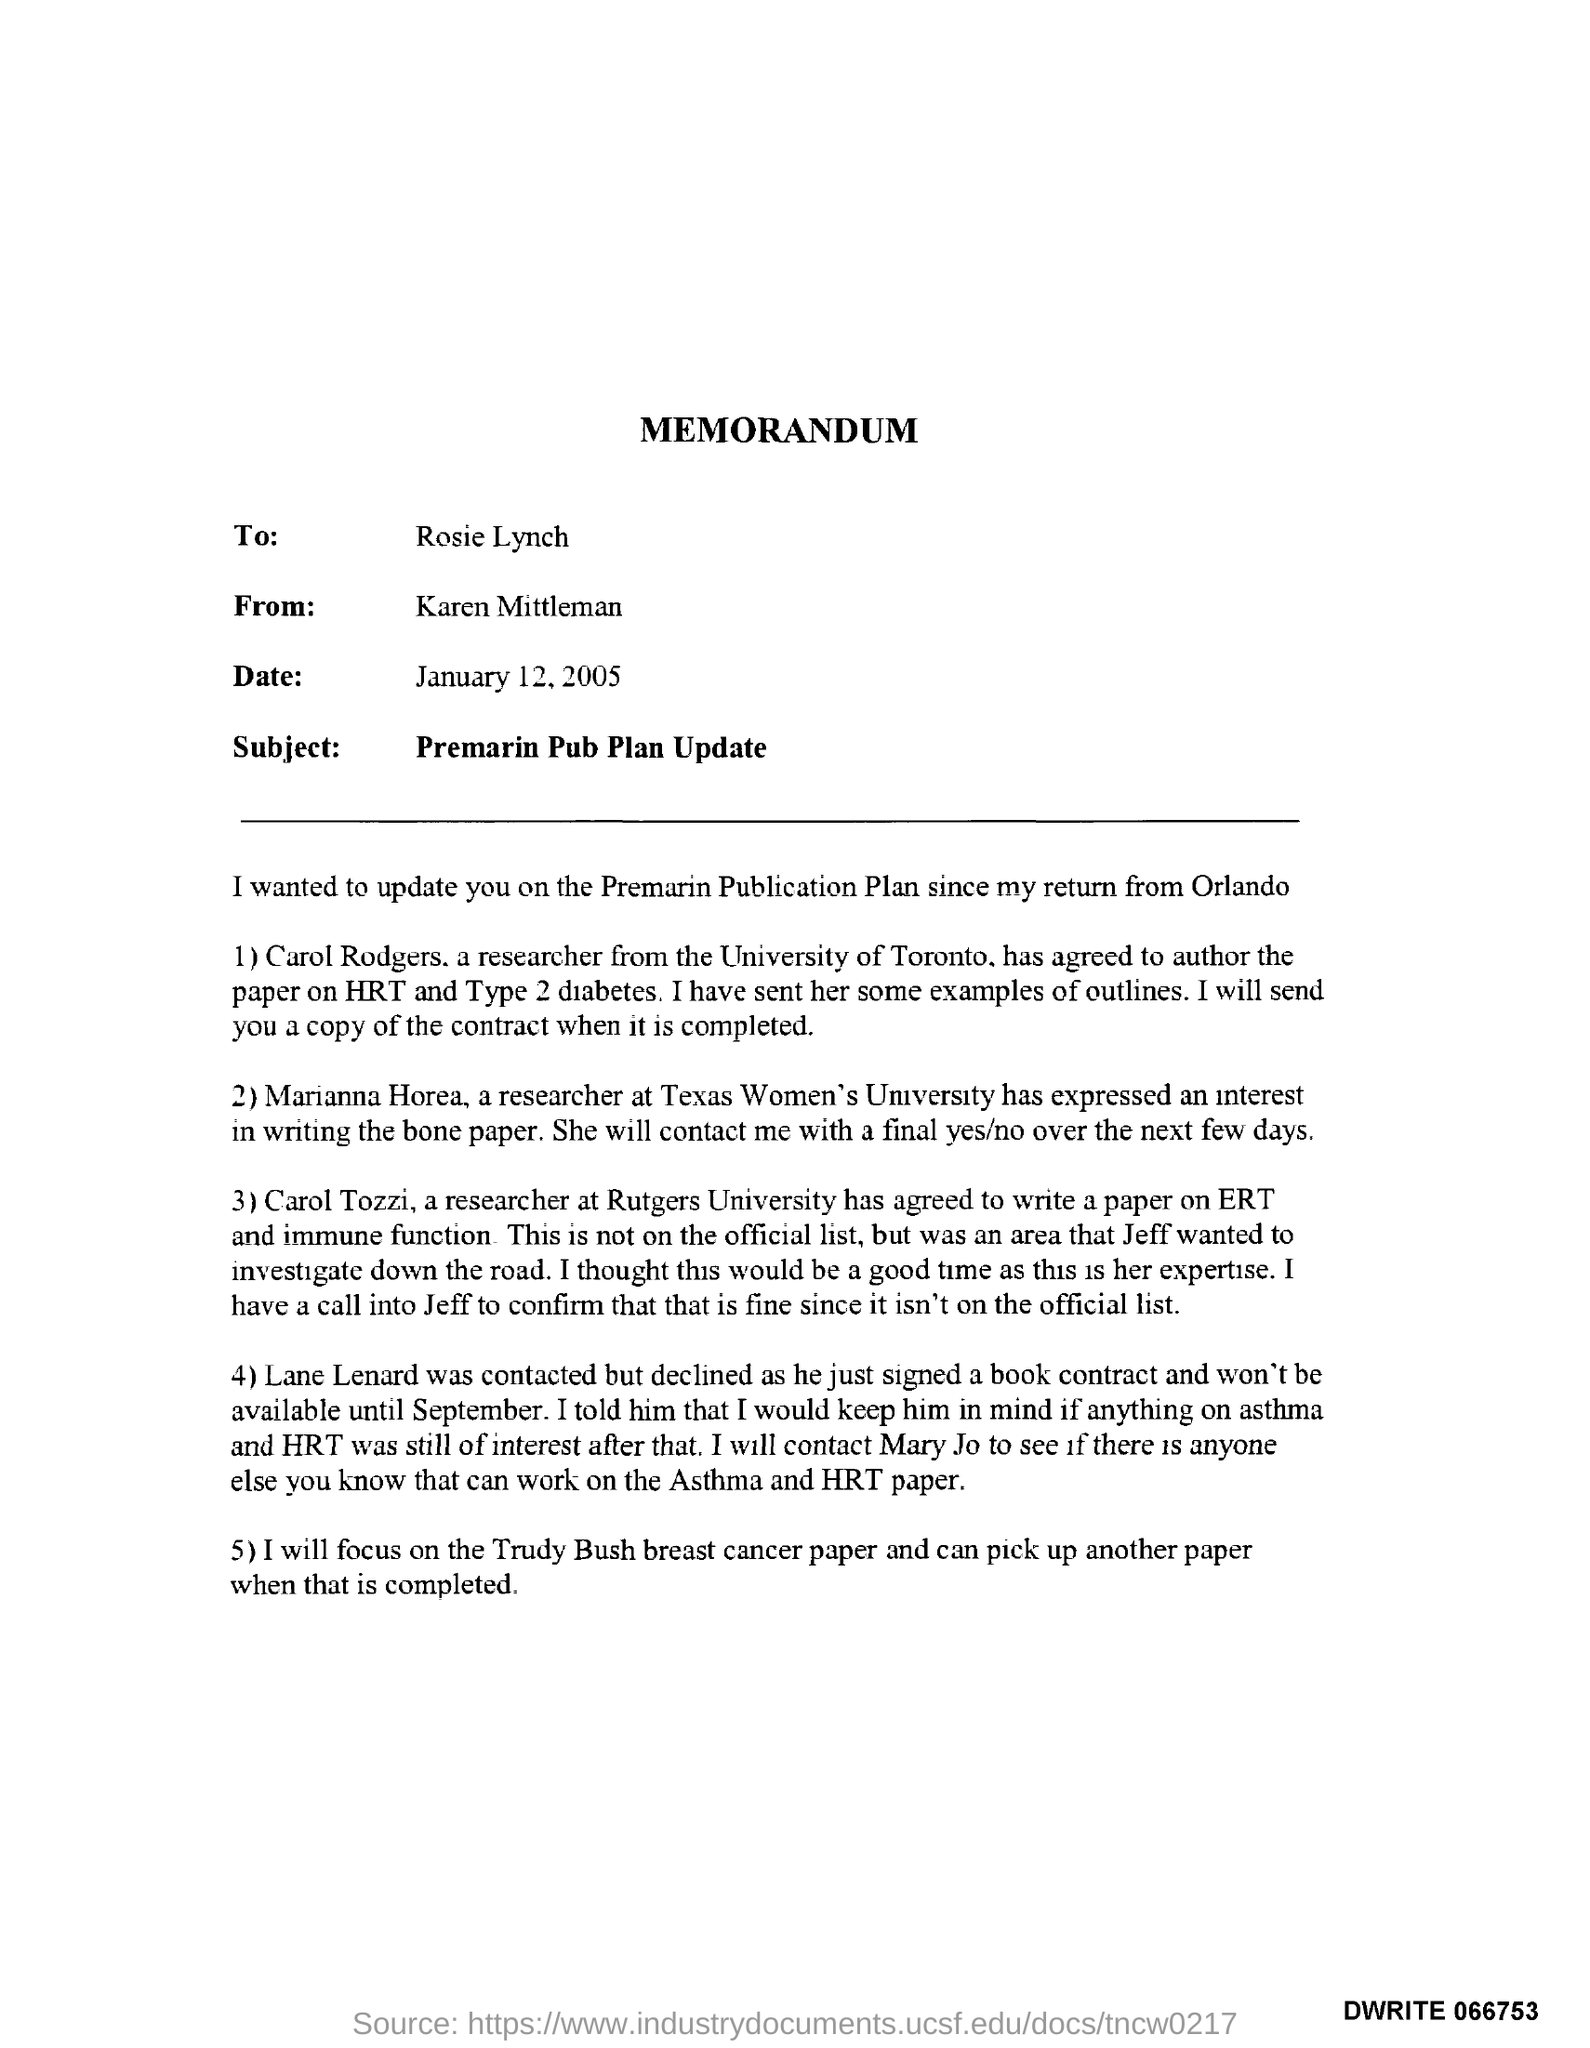Highlight a few significant elements in this photo. Rosie will focus on Trudy Bush's breast cancer paper. The subject of the memorandum is "Premarin Pub Plan Update. The memorandum was sent by Karen Mittleman. Carol Tozzi is a researcher at Rutgers University. Lane Lenard signed a contract for a book contract. 